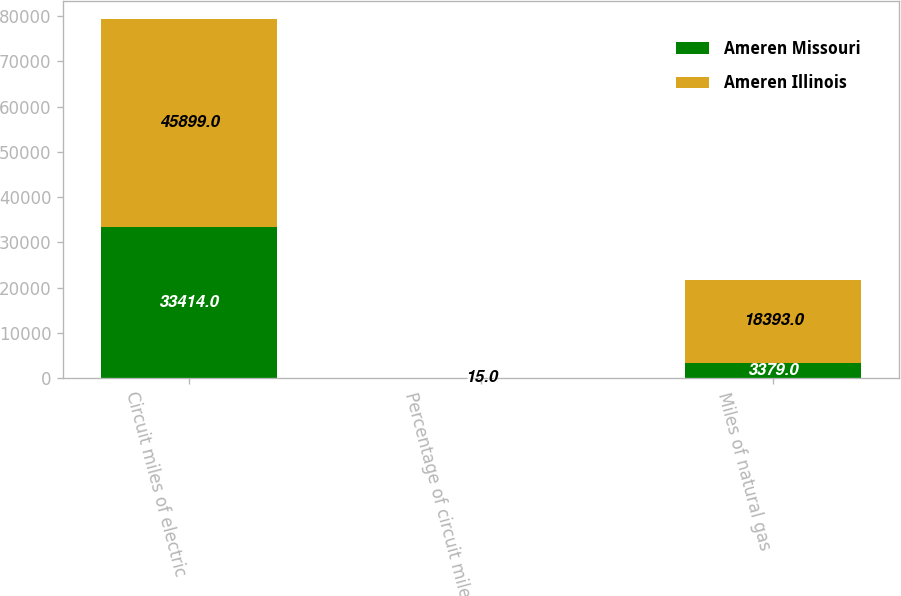<chart> <loc_0><loc_0><loc_500><loc_500><stacked_bar_chart><ecel><fcel>Circuit miles of electric<fcel>Percentage of circuit miles of<fcel>Miles of natural gas<nl><fcel>Ameren Missouri<fcel>33414<fcel>23<fcel>3379<nl><fcel>Ameren Illinois<fcel>45899<fcel>15<fcel>18393<nl></chart> 